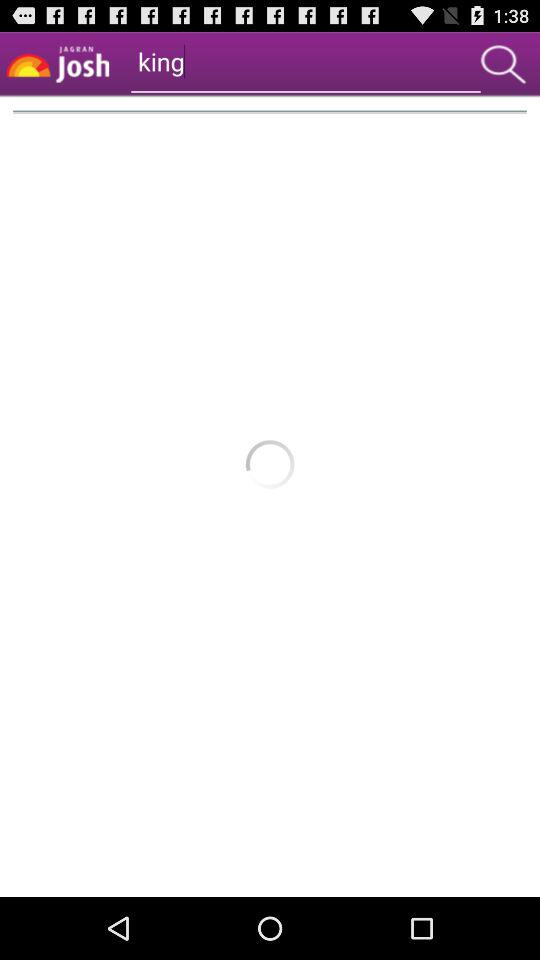What is the text written in the search bar? The text written in the search bar is "king". 